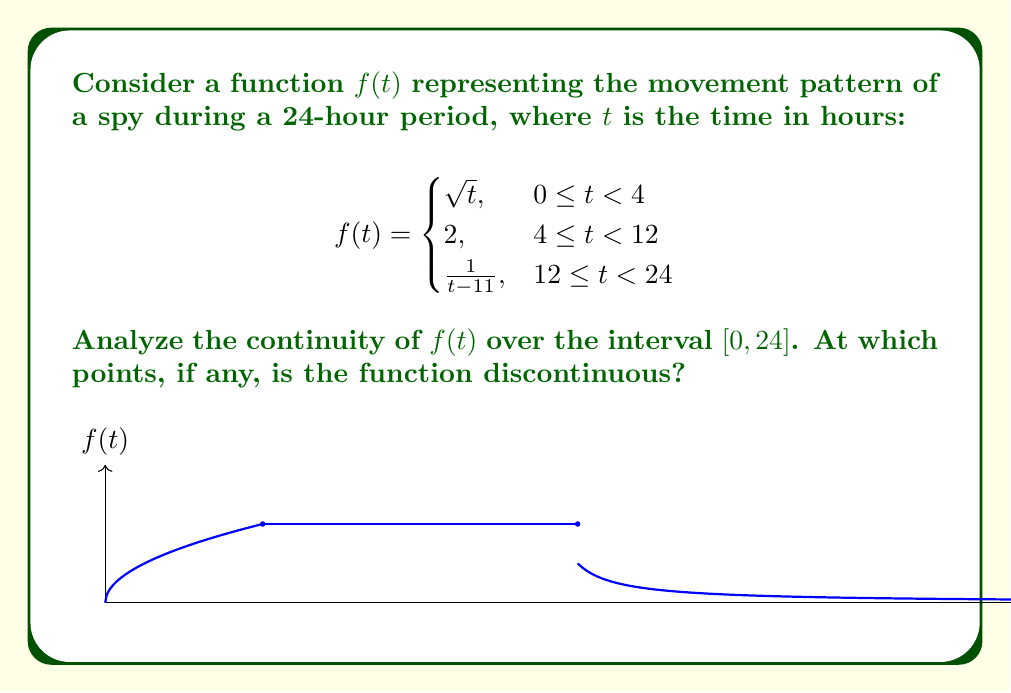Provide a solution to this math problem. To analyze the continuity of $f(t)$, we need to check for continuity at each piecewise boundary and within each piece:

1. Continuity at $t = 4$:
   Left limit: $\lim_{t \to 4^-} f(t) = \lim_{t \to 4^-} \sqrt{t} = 2$
   Right limit: $\lim_{t \to 4^+} f(t) = 2$
   $f(4) = 2$
   All three values are equal, so $f(t)$ is continuous at $t = 4$.

2. Continuity at $t = 12$:
   Left limit: $\lim_{t \to 12^-} f(t) = 2$
   Right limit: $\lim_{t \to 12^+} f(t) = \lim_{t \to 12^+} \frac{1}{t-11} = 1$
   $f(12) = \frac{1}{12-11} = 1$
   The left limit doesn't equal the right limit, so $f(t)$ is discontinuous at $t = 12$.

3. Continuity within each piece:
   - $\sqrt{t}$ is continuous on $[0, 4)$
   - The constant function 2 is continuous on $[4, 12)$
   - $\frac{1}{t-11}$ is continuous on $(12, 24)$, but undefined at $t = 11$ (which is not in this interval)

4. Endpoints:
   - At $t = 0$, $f(0) = 0$, which matches the limit as $t$ approaches 0 from the right.
   - At $t = 24$, $\lim_{t \to 24^-} f(t) = \frac{1}{13} \approx 0.0769$, which exists.

Therefore, $f(t)$ is discontinuous only at $t = 12$.
Answer: $f(t)$ is discontinuous at $t = 12$. 